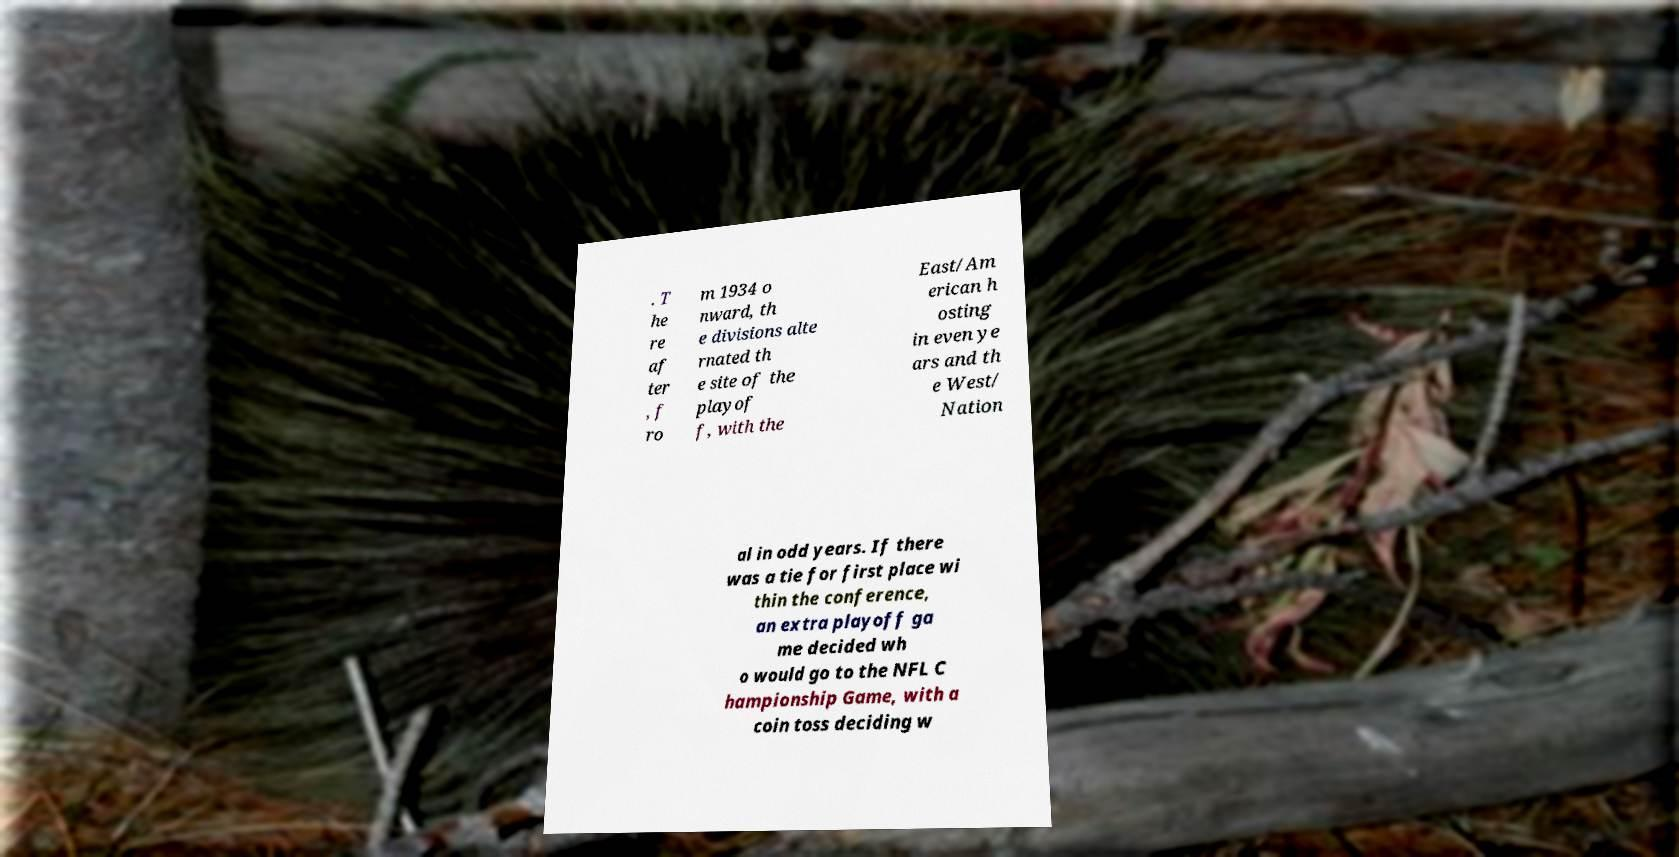What messages or text are displayed in this image? I need them in a readable, typed format. . T he re af ter , f ro m 1934 o nward, th e divisions alte rnated th e site of the playof f, with the East/Am erican h osting in even ye ars and th e West/ Nation al in odd years. If there was a tie for first place wi thin the conference, an extra playoff ga me decided wh o would go to the NFL C hampionship Game, with a coin toss deciding w 